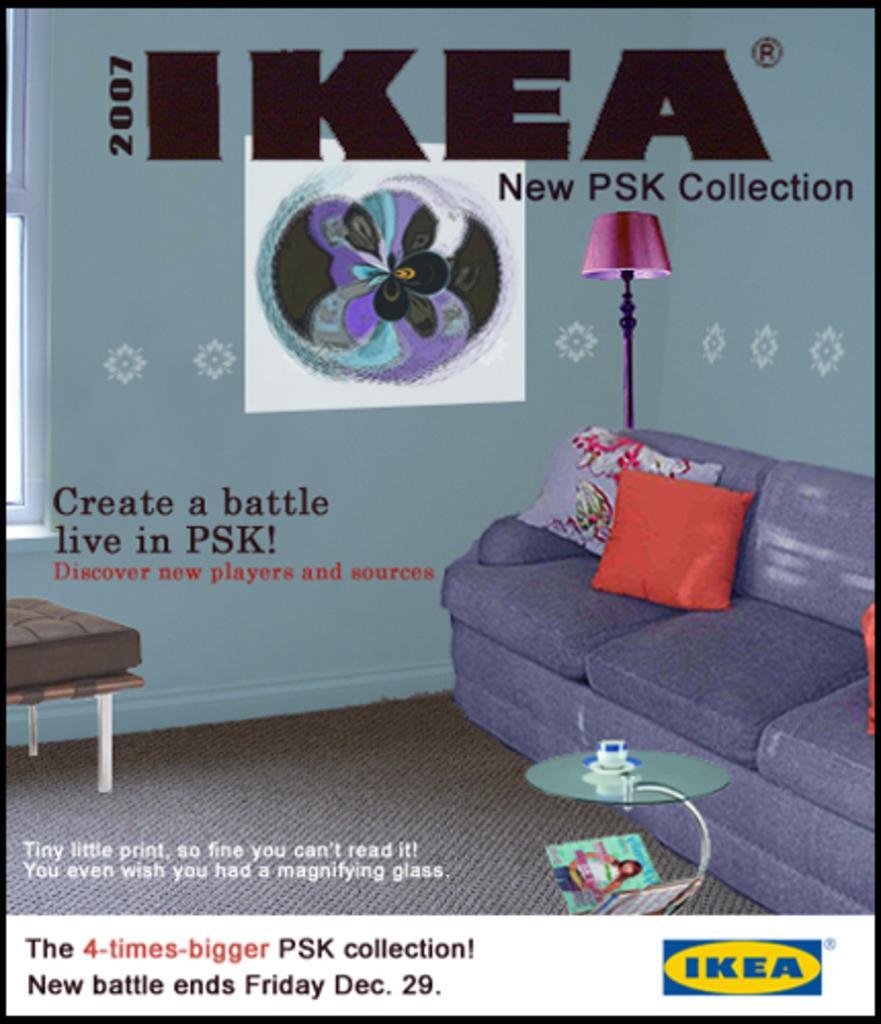How would you summarize this image in a sentence or two? In this picture we can see an image with sofa. This is the pillow. And there is a lamp. And this is floor. 